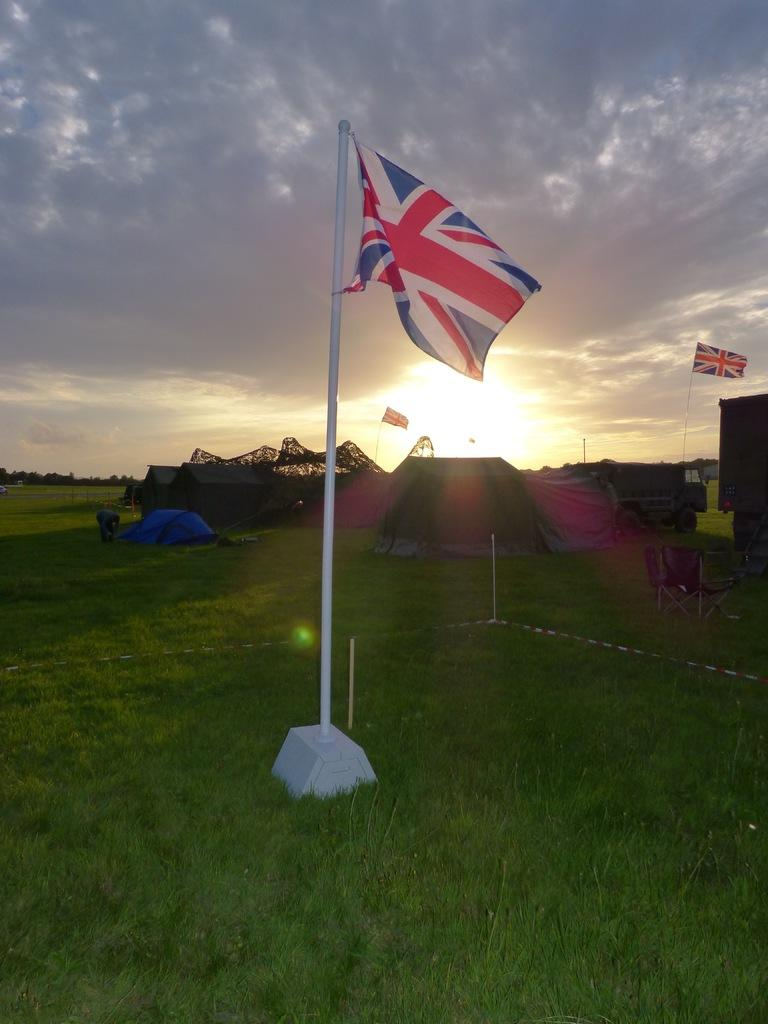What objects with poles can be seen in the image? There are flags with poles in the image. What type of terrain is visible in the image? There is grass in the image. What type of temporary shelters are present in the image? There are tents in the image. Can you describe the person in the image? There is a person in the image. What type of transportation is visible in the image? There are vehicles in the image. What type of seating is available in the image? There are chairs in the image. What type of vegetation is present in the image? There are trees in the image. What is visible in the background of the image? The sky is visible in the background of the image. What type of leather is being used to make the popcorn in the image? There is no popcorn or leather present in the image. Can you describe the daughter of the person in the image? There is no mention of a daughter or any other family members in the image. 